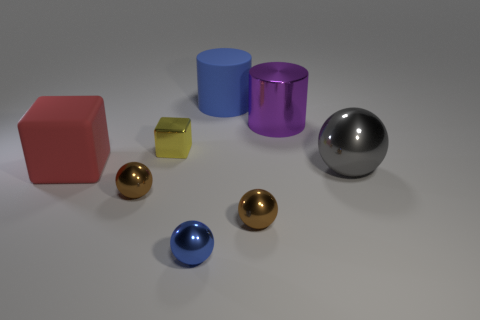What is the large gray ball made of?
Your response must be concise. Metal. The big ball that is the same material as the big purple cylinder is what color?
Ensure brevity in your answer.  Gray. There is a cylinder that is to the right of the big blue matte cylinder; is there a blue ball right of it?
Keep it short and to the point. No. How many other objects are the same shape as the big purple metallic object?
Your response must be concise. 1. There is a rubber object in front of the yellow shiny cube; is its shape the same as the thing behind the metallic cylinder?
Your answer should be very brief. No. How many small blue metal things are in front of the tiny sphere that is in front of the small metallic ball right of the tiny blue object?
Provide a short and direct response. 0. What is the color of the large matte cylinder?
Your answer should be very brief. Blue. How many other objects are there of the same size as the rubber cylinder?
Provide a succinct answer. 3. What material is the big thing that is the same shape as the tiny blue object?
Ensure brevity in your answer.  Metal. What is the brown object that is on the left side of the small object on the right side of the matte thing that is to the right of the tiny yellow object made of?
Offer a terse response. Metal. 